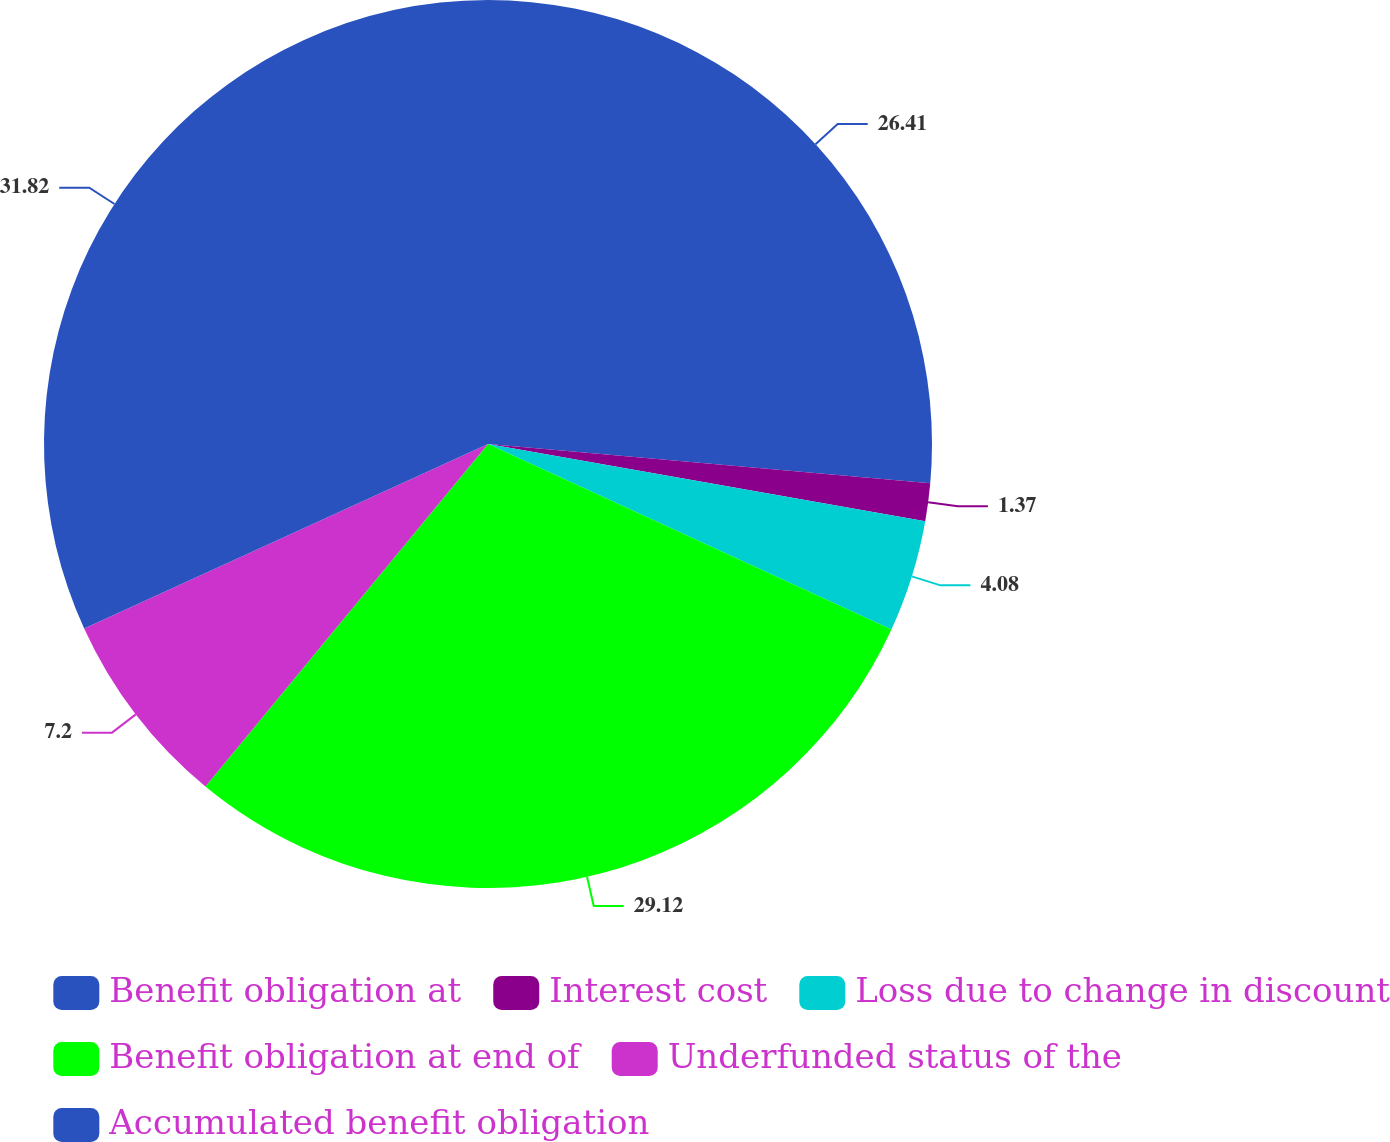Convert chart. <chart><loc_0><loc_0><loc_500><loc_500><pie_chart><fcel>Benefit obligation at<fcel>Interest cost<fcel>Loss due to change in discount<fcel>Benefit obligation at end of<fcel>Underfunded status of the<fcel>Accumulated benefit obligation<nl><fcel>26.41%<fcel>1.37%<fcel>4.08%<fcel>29.12%<fcel>7.2%<fcel>31.82%<nl></chart> 